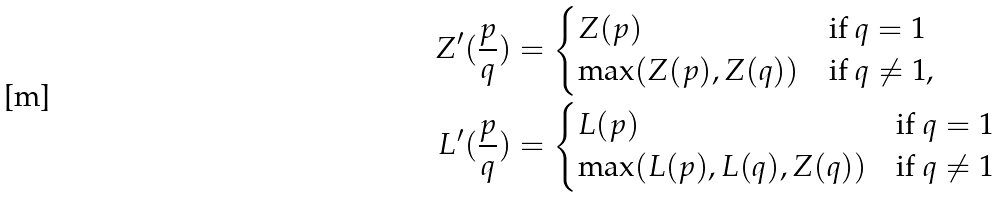<formula> <loc_0><loc_0><loc_500><loc_500>Z ^ { \prime } ( \frac { p } { q } ) & = \begin{cases} Z ( p ) & \text {if $q=1$} \\ \max ( Z ( p ) , Z ( q ) ) & \text {if $q\neq1$} , \end{cases} \\ L ^ { \prime } ( \frac { p } { q } ) & = \begin{cases} L ( p ) & \text {if $q=1$} \\ \max ( L ( p ) , L ( q ) , Z ( q ) ) & \text {if $q\neq1$} \end{cases}</formula> 